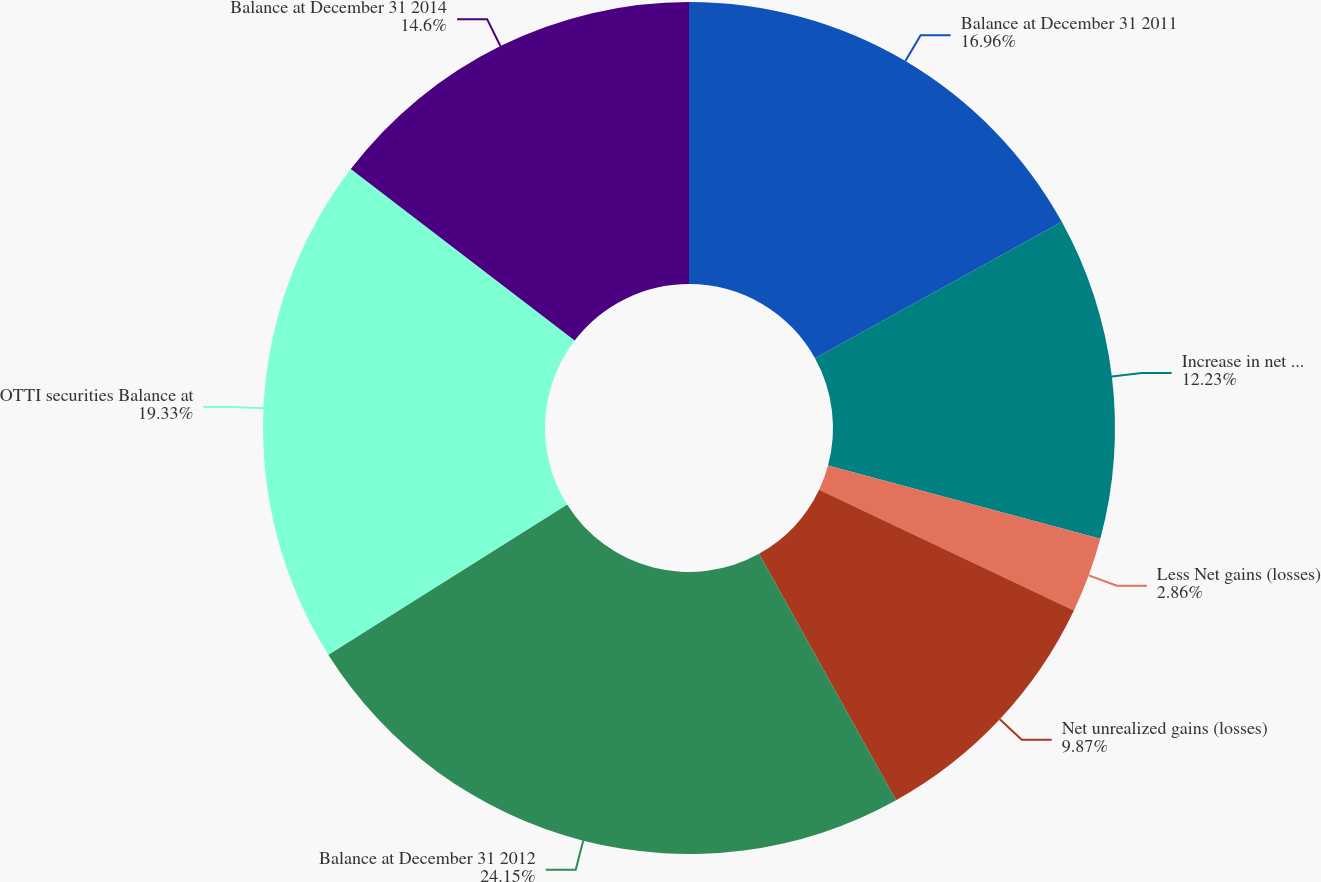Convert chart. <chart><loc_0><loc_0><loc_500><loc_500><pie_chart><fcel>Balance at December 31 2011<fcel>Increase in net unrealized<fcel>Less Net gains (losses)<fcel>Net unrealized gains (losses)<fcel>Balance at December 31 2012<fcel>OTTI securities Balance at<fcel>Balance at December 31 2014<nl><fcel>16.96%<fcel>12.23%<fcel>2.86%<fcel>9.87%<fcel>24.15%<fcel>19.33%<fcel>14.6%<nl></chart> 